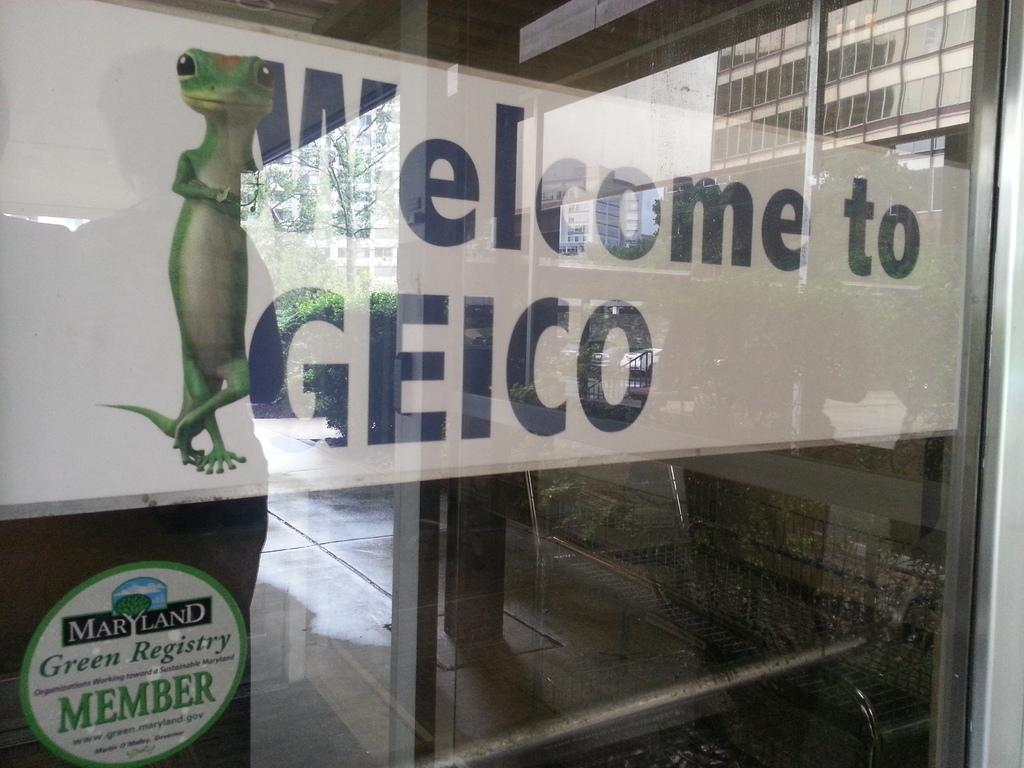What type of door is visible in the image? There is a glass door in the image. What is unique about the glass door? The glass door has text and an image on it. What can be seen through the glass door? Trees and buildings are visible through the glass door. What color is the eye visible in the image? There is no eye present in the image. 